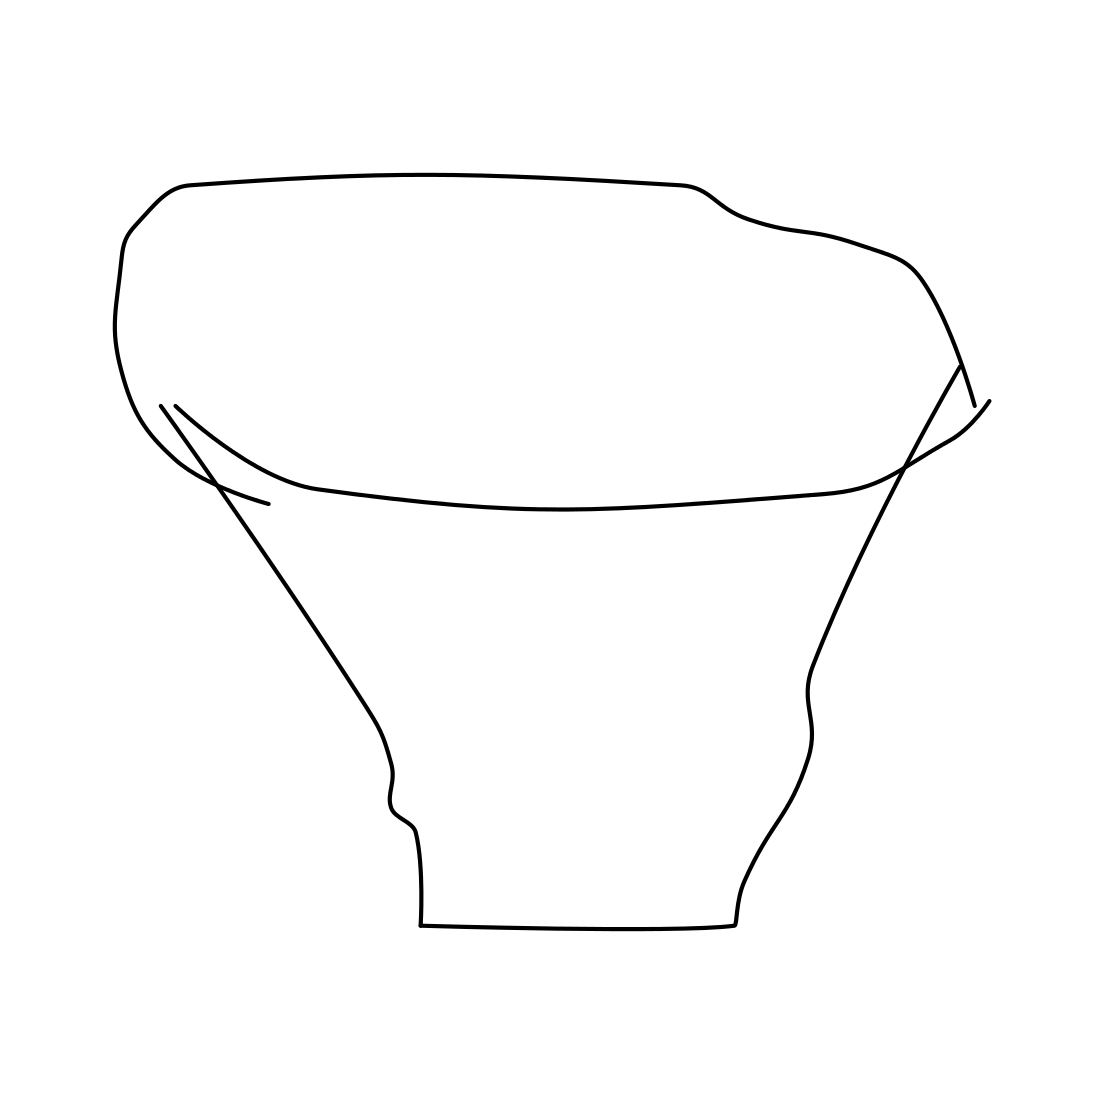What is this object used for? This object appears to be a line drawing of a pot, which is typically used for holding plants, storing items, or as a container for food or liquids in various contexts, depending on its material and size. 